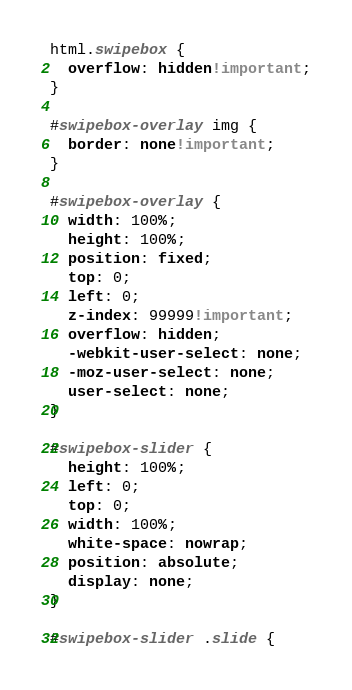Convert code to text. <code><loc_0><loc_0><loc_500><loc_500><_CSS_>html.swipebox {
  overflow: hidden!important;
}

#swipebox-overlay img {
  border: none!important;
}

#swipebox-overlay {
  width: 100%;
  height: 100%;
  position: fixed;
  top: 0;
  left: 0;
  z-index: 99999!important;
  overflow: hidden;
  -webkit-user-select: none;
  -moz-user-select: none;
  user-select: none;
}

#swipebox-slider {
  height: 100%;
  left: 0;
  top: 0;
  width: 100%;
  white-space: nowrap;
  position: absolute;
  display: none;
}

#swipebox-slider .slide {</code> 